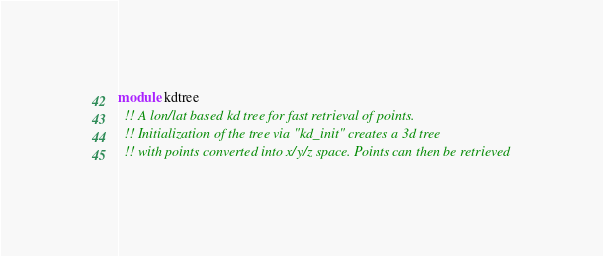<code> <loc_0><loc_0><loc_500><loc_500><_FORTRAN_>module kdtree
  !! A lon/lat based kd tree for fast retrieval of points.
  !! Initialization of the tree via "kd_init" creates a 3d tree
  !! with points converted into x/y/z space. Points can then be retrieved</code> 